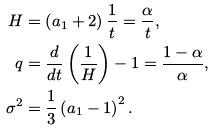Convert formula to latex. <formula><loc_0><loc_0><loc_500><loc_500>H & = \left ( a _ { 1 } + 2 \right ) \frac { 1 } { t } = \frac { \alpha } { t } , \\ q & = \frac { d } { d t } \left ( \frac { 1 } { H } \right ) - 1 = \frac { 1 - \alpha } { \alpha } , \\ \sigma ^ { 2 } & = \frac { 1 } { 3 } \left ( a _ { 1 } - 1 \right ) ^ { 2 } .</formula> 